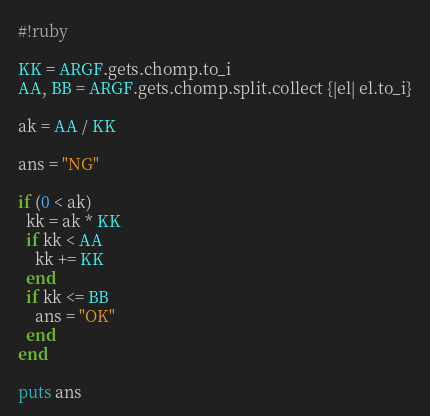Convert code to text. <code><loc_0><loc_0><loc_500><loc_500><_Ruby_>#!ruby

KK = ARGF.gets.chomp.to_i
AA, BB = ARGF.gets.chomp.split.collect {|el| el.to_i}

ak = AA / KK

ans = "NG"

if (0 < ak)
  kk = ak * KK
  if kk < AA
    kk += KK
  end
  if kk <= BB
    ans = "OK"
  end
end

puts ans
</code> 